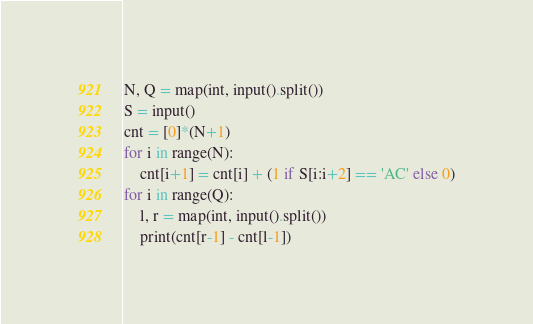<code> <loc_0><loc_0><loc_500><loc_500><_Python_>N, Q = map(int, input().split())
S = input()
cnt = [0]*(N+1)
for i in range(N):
    cnt[i+1] = cnt[i] + (1 if S[i:i+2] == 'AC' else 0)
for i in range(Q):
    l, r = map(int, input().split())
    print(cnt[r-1] - cnt[l-1])
</code> 